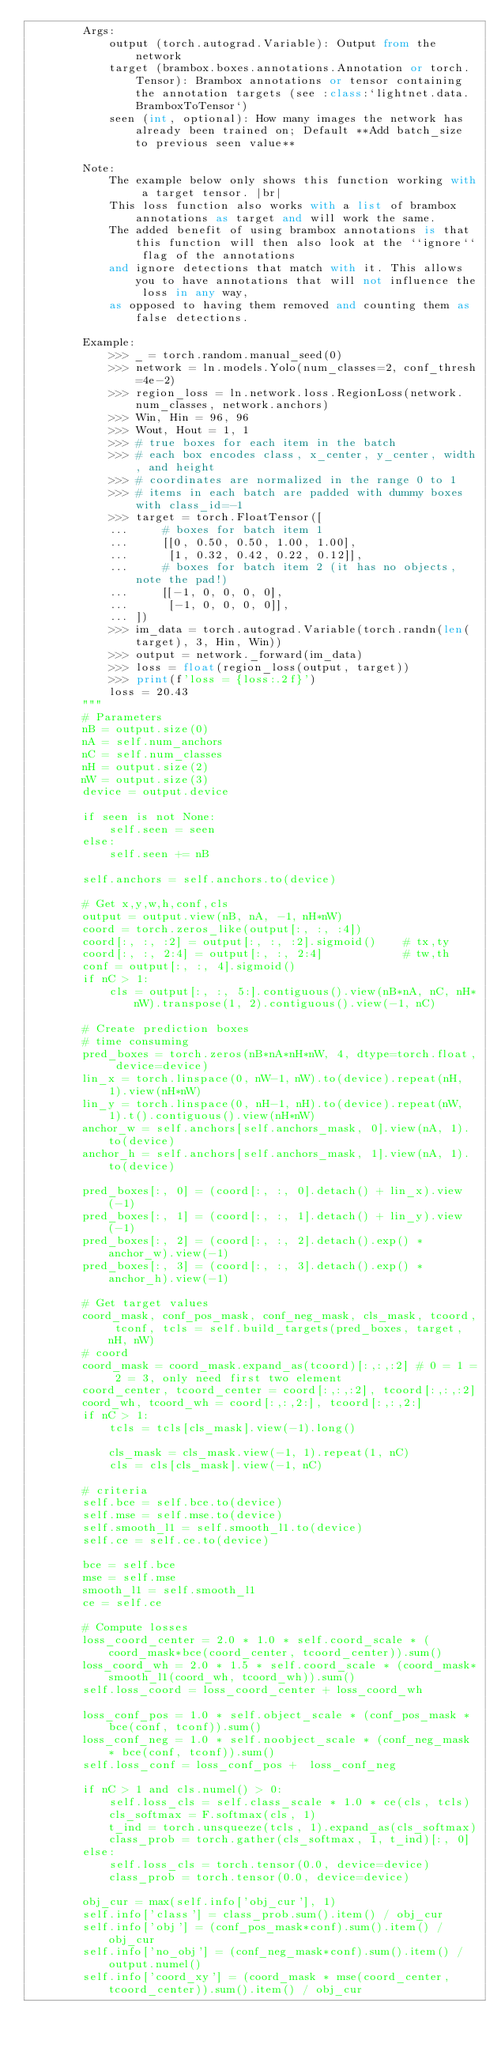Convert code to text. <code><loc_0><loc_0><loc_500><loc_500><_Python_>        Args:
            output (torch.autograd.Variable): Output from the network
            target (brambox.boxes.annotations.Annotation or torch.Tensor): Brambox annotations or tensor containing the annotation targets (see :class:`lightnet.data.BramboxToTensor`)
            seen (int, optional): How many images the network has already been trained on; Default **Add batch_size to previous seen value**

        Note:
            The example below only shows this function working with a target tensor. |br|
            This loss function also works with a list of brambox annotations as target and will work the same.
            The added benefit of using brambox annotations is that this function will then also look at the ``ignore`` flag of the annotations
            and ignore detections that match with it. This allows you to have annotations that will not influence the loss in any way,
            as opposed to having them removed and counting them as false detections.

        Example:
            >>> _ = torch.random.manual_seed(0)
            >>> network = ln.models.Yolo(num_classes=2, conf_thresh=4e-2)
            >>> region_loss = ln.network.loss.RegionLoss(network.num_classes, network.anchors)
            >>> Win, Hin = 96, 96
            >>> Wout, Hout = 1, 1
            >>> # true boxes for each item in the batch
            >>> # each box encodes class, x_center, y_center, width, and height
            >>> # coordinates are normalized in the range 0 to 1
            >>> # items in each batch are padded with dummy boxes with class_id=-1
            >>> target = torch.FloatTensor([
            ...     # boxes for batch item 1
            ...     [[0, 0.50, 0.50, 1.00, 1.00],
            ...      [1, 0.32, 0.42, 0.22, 0.12]],
            ...     # boxes for batch item 2 (it has no objects, note the pad!)
            ...     [[-1, 0, 0, 0, 0],
            ...      [-1, 0, 0, 0, 0]],
            ... ])
            >>> im_data = torch.autograd.Variable(torch.randn(len(target), 3, Hin, Win))
            >>> output = network._forward(im_data)
            >>> loss = float(region_loss(output, target))
            >>> print(f'loss = {loss:.2f}')
            loss = 20.43
        """
        # Parameters
        nB = output.size(0)
        nA = self.num_anchors
        nC = self.num_classes
        nH = output.size(2)
        nW = output.size(3)
        device = output.device

        if seen is not None:
            self.seen = seen
        else:
            self.seen += nB

        self.anchors = self.anchors.to(device)

        # Get x,y,w,h,conf,cls
        output = output.view(nB, nA, -1, nH*nW)
        coord = torch.zeros_like(output[:, :, :4])
        coord[:, :, :2] = output[:, :, :2].sigmoid()    # tx,ty
        coord[:, :, 2:4] = output[:, :, 2:4]            # tw,th
        conf = output[:, :, 4].sigmoid()
        if nC > 1:
            cls = output[:, :, 5:].contiguous().view(nB*nA, nC, nH*nW).transpose(1, 2).contiguous().view(-1, nC)

        # Create prediction boxes
        # time consuming
        pred_boxes = torch.zeros(nB*nA*nH*nW, 4, dtype=torch.float, device=device)
        lin_x = torch.linspace(0, nW-1, nW).to(device).repeat(nH, 1).view(nH*nW)
        lin_y = torch.linspace(0, nH-1, nH).to(device).repeat(nW, 1).t().contiguous().view(nH*nW)
        anchor_w = self.anchors[self.anchors_mask, 0].view(nA, 1).to(device) 
        anchor_h = self.anchors[self.anchors_mask, 1].view(nA, 1).to(device)

        pred_boxes[:, 0] = (coord[:, :, 0].detach() + lin_x).view(-1)
        pred_boxes[:, 1] = (coord[:, :, 1].detach() + lin_y).view(-1)
        pred_boxes[:, 2] = (coord[:, :, 2].detach().exp() * anchor_w).view(-1)
        pred_boxes[:, 3] = (coord[:, :, 3].detach().exp() * anchor_h).view(-1)

        # Get target values
        coord_mask, conf_pos_mask, conf_neg_mask, cls_mask, tcoord, tconf, tcls = self.build_targets(pred_boxes, target, nH, nW)
        # coord
        coord_mask = coord_mask.expand_as(tcoord)[:,:,:2] # 0 = 1 = 2 = 3, only need first two element
        coord_center, tcoord_center = coord[:,:,:2], tcoord[:,:,:2]
        coord_wh, tcoord_wh = coord[:,:,2:], tcoord[:,:,2:]
        if nC > 1:
            tcls = tcls[cls_mask].view(-1).long()

            cls_mask = cls_mask.view(-1, 1).repeat(1, nC)
            cls = cls[cls_mask].view(-1, nC)

        # criteria
        self.bce = self.bce.to(device)
        self.mse = self.mse.to(device)
        self.smooth_l1 = self.smooth_l1.to(device)
        self.ce = self.ce.to(device)

        bce = self.bce
        mse = self.mse
        smooth_l1 = self.smooth_l1
        ce = self.ce

        # Compute losses
        loss_coord_center = 2.0 * 1.0 * self.coord_scale * (coord_mask*bce(coord_center, tcoord_center)).sum()
        loss_coord_wh = 2.0 * 1.5 * self.coord_scale * (coord_mask*smooth_l1(coord_wh, tcoord_wh)).sum()
        self.loss_coord = loss_coord_center + loss_coord_wh

        loss_conf_pos = 1.0 * self.object_scale * (conf_pos_mask * bce(conf, tconf)).sum()
        loss_conf_neg = 1.0 * self.noobject_scale * (conf_neg_mask * bce(conf, tconf)).sum() 
        self.loss_conf = loss_conf_pos +  loss_conf_neg 

        if nC > 1 and cls.numel() > 0:
            self.loss_cls = self.class_scale * 1.0 * ce(cls, tcls)
            cls_softmax = F.softmax(cls, 1)
            t_ind = torch.unsqueeze(tcls, 1).expand_as(cls_softmax)      
            class_prob = torch.gather(cls_softmax, 1, t_ind)[:, 0]
        else:
            self.loss_cls = torch.tensor(0.0, device=device)
            class_prob = torch.tensor(0.0, device=device)

        obj_cur = max(self.info['obj_cur'], 1)
        self.info['class'] = class_prob.sum().item() / obj_cur
        self.info['obj'] = (conf_pos_mask*conf).sum().item() / obj_cur
        self.info['no_obj'] = (conf_neg_mask*conf).sum().item() / output.numel()
        self.info['coord_xy'] = (coord_mask * mse(coord_center, tcoord_center)).sum().item() / obj_cur</code> 